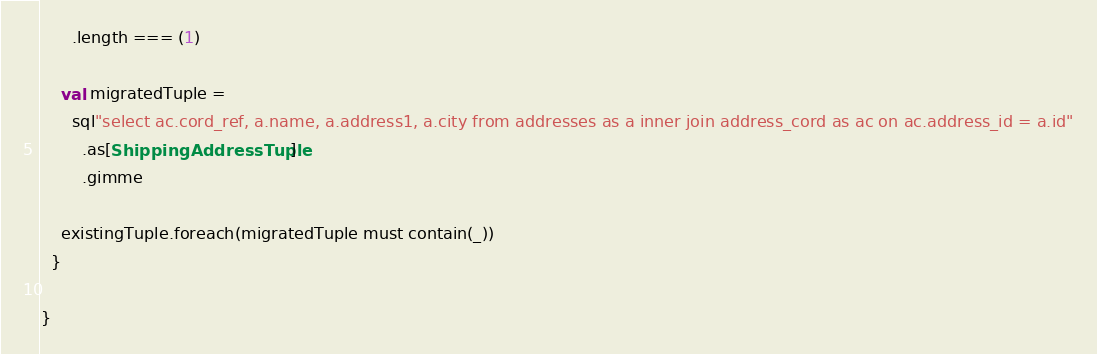<code> <loc_0><loc_0><loc_500><loc_500><_Scala_>      .length === (1)

    val migratedTuple =
      sql"select ac.cord_ref, a.name, a.address1, a.city from addresses as a inner join address_cord as ac on ac.address_id = a.id"
        .as[ShippingAddressTuple]
        .gimme

    existingTuple.foreach(migratedTuple must contain(_))
  }

}
</code> 